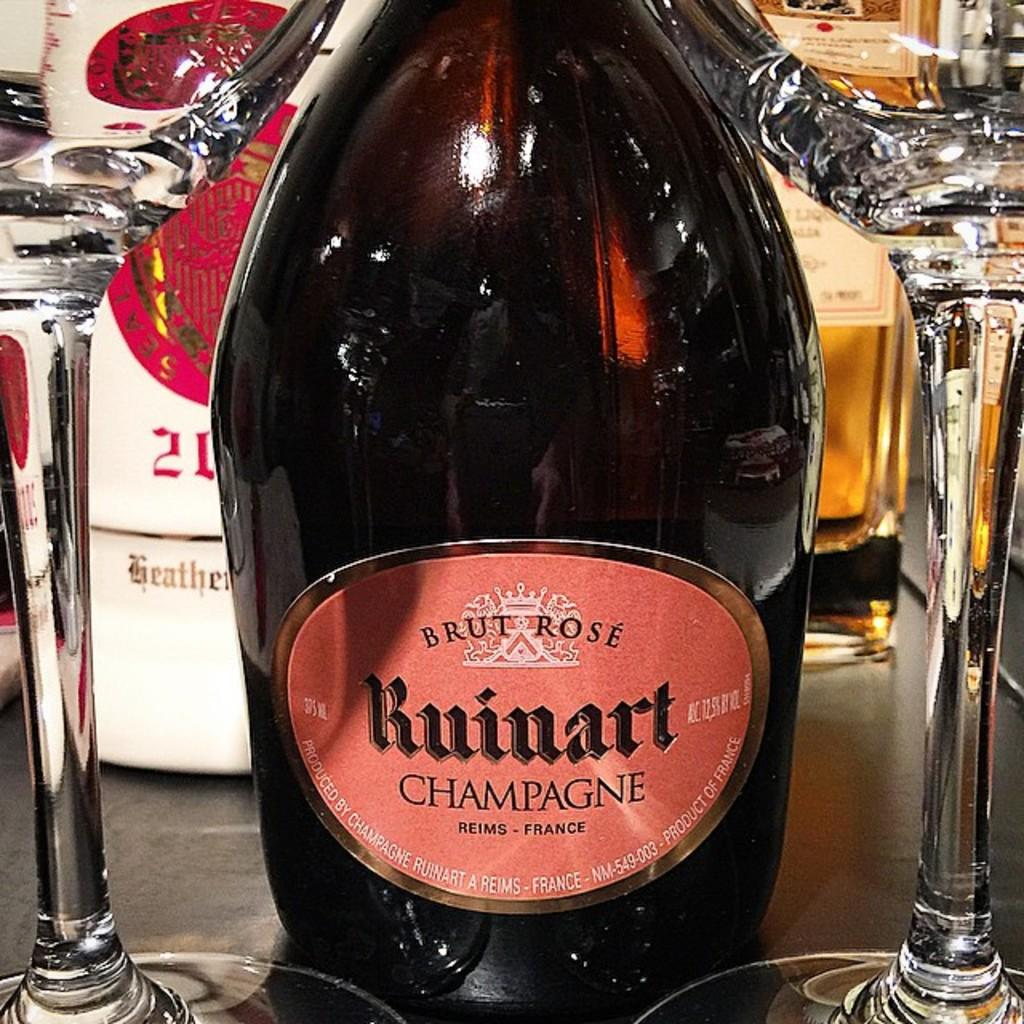Provide a one-sentence caption for the provided image. A bottle of champange is resting on a shelf with two glasses. 